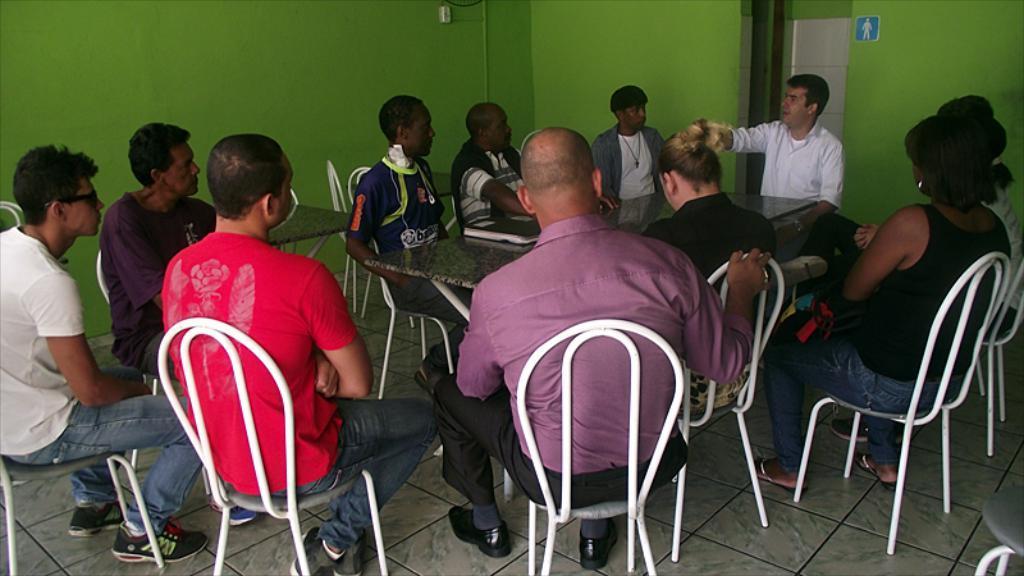How would you summarize this image in a sentence or two? In this image, group of people are sat on the white chair. At the bottom, there is a tile floor. Center so many tables are placed. The top of the image, we can see green color wall. 